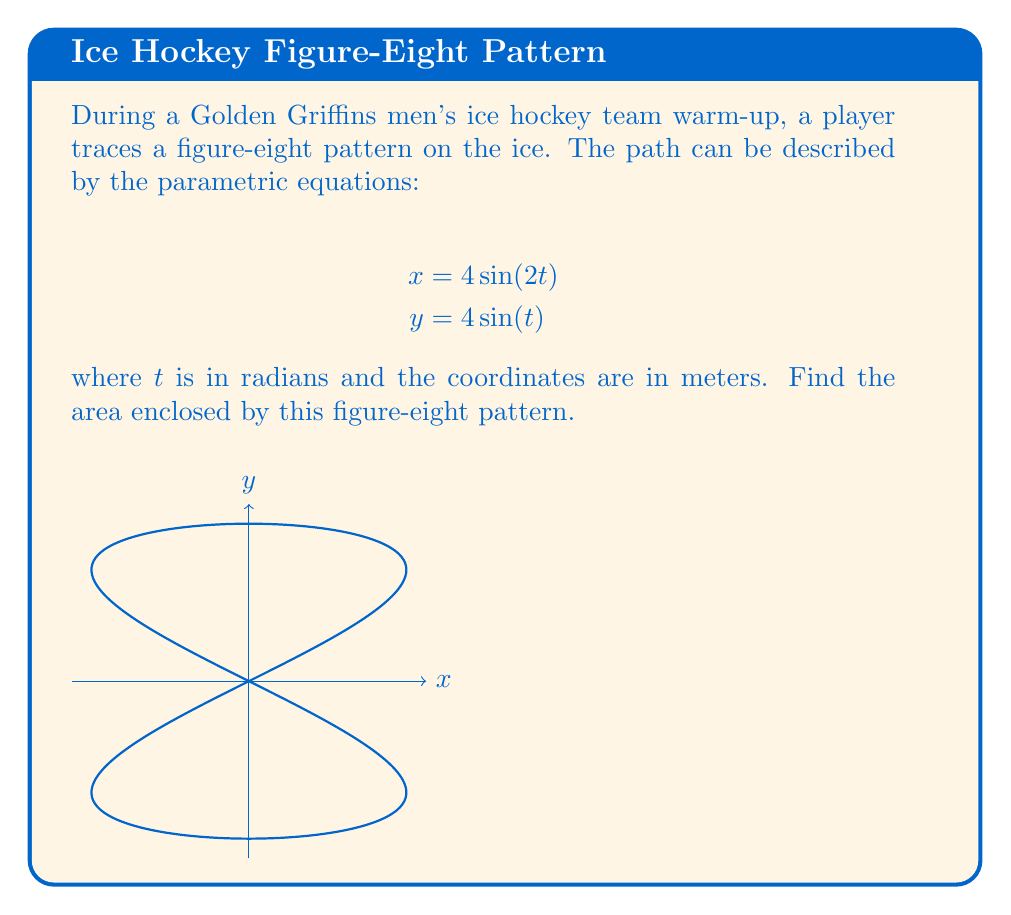Could you help me with this problem? To find the area enclosed by the figure-eight pattern, we'll use Green's Theorem in the plane. The area is given by:

$$A = \frac{1}{2} \int_C (x dy - y dx)$$

where $C$ is the closed curve of the figure-eight.

Steps:
1) First, we need to express $dx$ and $dy$ in terms of $dt$:
   $$dx = 8\cos(2t)dt$$
   $$dy = 4\cos(t)dt$$

2) Substitute these and the original equations into the area formula:
   $$A = \frac{1}{2} \int_0^{2\pi} (4\sin(2t) \cdot 4\cos(t) - 4\sin(t) \cdot 8\cos(2t)) dt$$

3) Simplify:
   $$A = \int_0^{2\pi} (8\sin(2t)\cos(t) - 16\sin(t)\cos(2t)) dt$$

4) Use trigonometric identities:
   $\sin(2t)\cos(t) = \sin(3t) + \sin(t)$
   $\sin(t)\cos(2t) = \frac{1}{2}(\sin(3t) - \sin(t))$

5) Substitute:
   $$A = \int_0^{2\pi} (8(\sin(3t) + \sin(t)) - 16(\frac{1}{2}(\sin(3t) - \sin(t)))) dt$$
   $$= \int_0^{2\pi} (8\sin(3t) + 8\sin(t) - 8\sin(3t) + 8\sin(t)) dt$$
   $$= \int_0^{2\pi} 16\sin(t) dt$$

6) Integrate:
   $$A = -16\cos(t) \bigg|_0^{2\pi} = -16(\cos(2\pi) - \cos(0)) = 0$$

The area enclosed by the figure-eight is zero because the two lobes have equal areas but are traced in opposite directions, canceling each other out.
Answer: $0$ square meters 